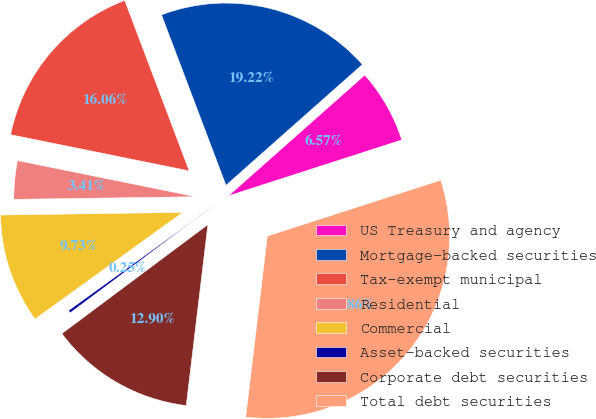<chart> <loc_0><loc_0><loc_500><loc_500><pie_chart><fcel>US Treasury and agency<fcel>Mortgage-backed securities<fcel>Tax-exempt municipal<fcel>Residential<fcel>Commercial<fcel>Asset-backed securities<fcel>Corporate debt securities<fcel>Total debt securities<nl><fcel>6.57%<fcel>19.22%<fcel>16.06%<fcel>3.41%<fcel>9.73%<fcel>0.25%<fcel>12.9%<fcel>31.86%<nl></chart> 